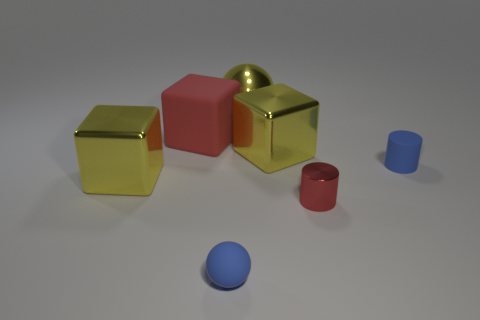What number of big things are the same color as the big matte cube?
Make the answer very short. 0. What number of other objects are the same color as the metallic cylinder?
Make the answer very short. 1. Is the number of large brown matte balls greater than the number of tiny blue rubber objects?
Offer a very short reply. No. What is the material of the large yellow sphere?
Give a very brief answer. Metal. Do the rubber object left of the rubber sphere and the small matte cylinder have the same size?
Your answer should be compact. No. How big is the ball that is in front of the big red matte cube?
Your response must be concise. Small. Are there any other things that are the same material as the large red object?
Your answer should be compact. Yes. How many tiny matte objects are there?
Keep it short and to the point. 2. Is the color of the big rubber thing the same as the tiny matte sphere?
Offer a terse response. No. What color is the metal object that is on the right side of the big rubber object and in front of the small matte cylinder?
Offer a terse response. Red. 